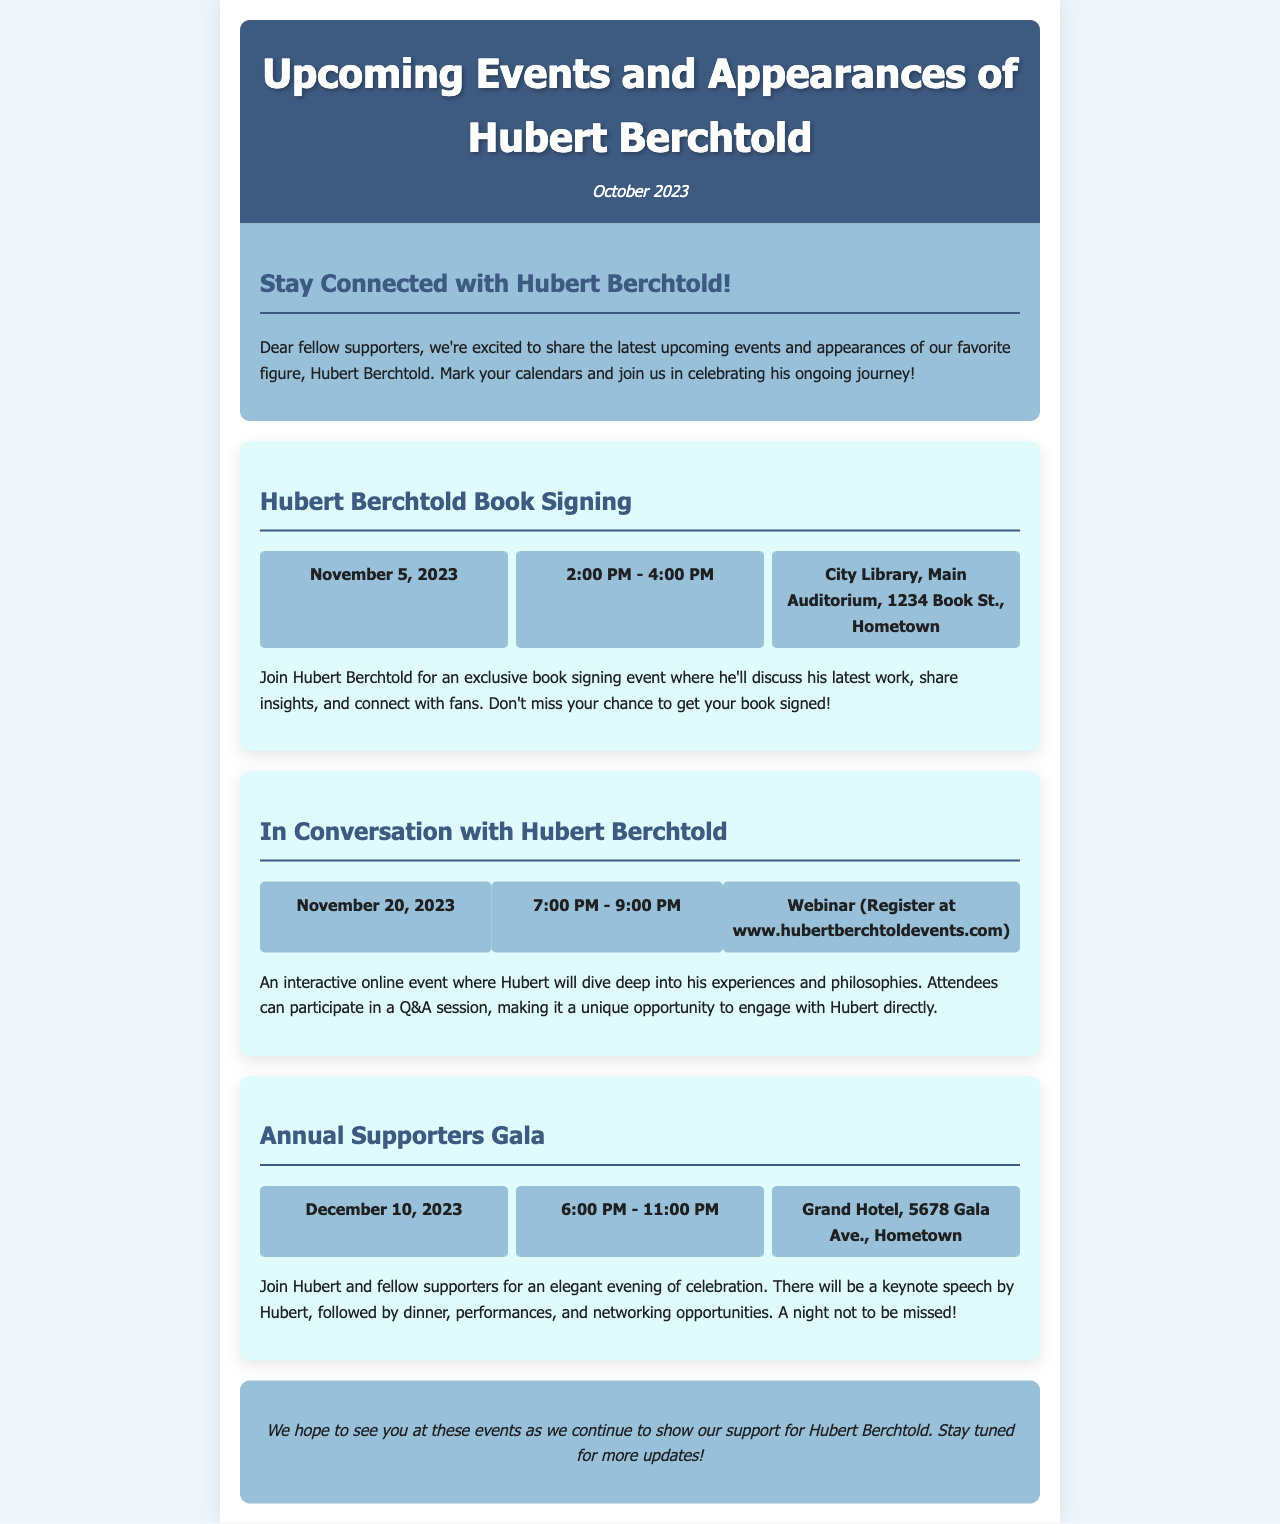What is the date of the book signing event? The document states that the book signing event is on November 5, 2023.
Answer: November 5, 2023 How long is the "In Conversation with Hubert Berchtold" event? The event runs from 7:00 PM to 9:00 PM, which makes it 2 hours long.
Answer: 2 hours Where will the Annual Supporters Gala take place? The gala is happening at the Grand Hotel, 5678 Gala Ave., Hometown.
Answer: Grand Hotel, 5678 Gala Ave., Hometown What can attendees expect at the book signing event? Attendees can expect Hubert to discuss his latest work, share insights, and connect with fans.
Answer: Discuss his latest work What is the registration requirement for the "In Conversation" event? Attendees must register at www.hubertberchtoldevents.com to participate in the webinar.
Answer: Register at www.hubertberchtoldevents.com What kind of speech will Hubert give at the Annual Supporters Gala? Hubert will give a keynote speech at the gala.
Answer: Keynote speech What is the primary purpose of the newsletter? The newsletter aims to share upcoming events and appearances of Hubert Berchtold.
Answer: Share upcoming events How many events are listed in the newsletter? The newsletter lists a total of three events.
Answer: Three events 